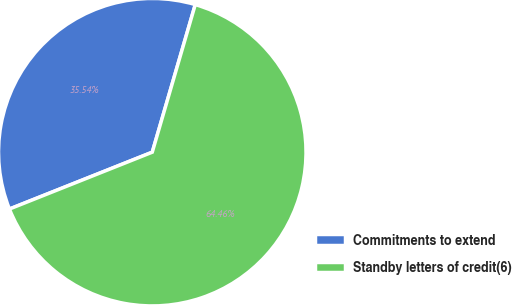<chart> <loc_0><loc_0><loc_500><loc_500><pie_chart><fcel>Commitments to extend<fcel>Standby letters of credit(6)<nl><fcel>35.54%<fcel>64.46%<nl></chart> 